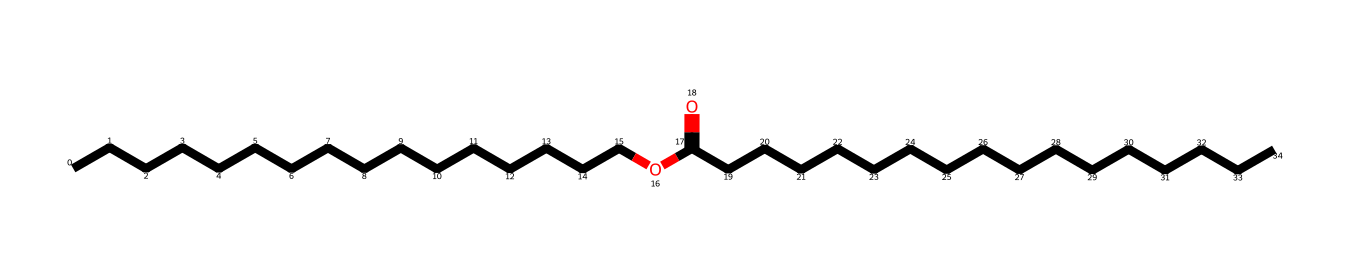What is the molecular formula of the compound? The SMILES representation indicates the presence of carbon (C), hydrogen (H), and oxygen (O) atoms. Counting the carbon atoms, there are 30 (from the two chains), and estimating the number of hydrogen atoms gives 60, while the oxygen is singular. Therefore, the molecular formula is C30H60O.
Answer: C30H60O How many carbon atoms are in the structure? The structure represented by the SMILES shows two long carbon chains, each with 15 carbon atoms, adding up to a total of 30 carbon atoms.
Answer: 30 What type of functional group is present in this chemical? In the SMILES notation, the 'OC(=O)' indicates the presence of an ester functional group, which is typical in fatty acid esters, derived from the reaction of an alcohol and a carboxylic acid.
Answer: ester What state is this chemical likely in at room temperature? Considering the structure is a long-chain fatty acid ester, it is likely to be solid at room temperature, reflecting the properties of similar compounds like beeswax, which is solid due to its molecular weight and structure.
Answer: solid Why is this chemical suitable for lubrication in woodworking? The long carbon chains and the ester functional group provide a viscous consistency that reduces friction, making it effective as a lubricant. Additionally, its hydrophobic nature helps protect wood surfaces from water damage.
Answer: viscous and hydrophobic How many double bonds are present in the structure? The SMILES notation shows no double bonds between carbon atoms except for the carbonyl (C=O) in the ester group. Therefore, there are no carbon-carbon double bonds in this structure.
Answer: 0 